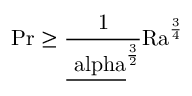Convert formula to latex. <formula><loc_0><loc_0><loc_500><loc_500>{ P r } \geq \frac { 1 } { \underline { \ a l p h a } ^ { \frac { 3 } { 2 } } } \mathrm { R a } ^ { \frac { 3 } { 4 } }</formula> 